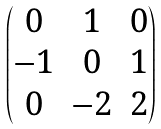<formula> <loc_0><loc_0><loc_500><loc_500>\begin{pmatrix} 0 & 1 & 0 \\ - 1 & 0 & 1 \\ 0 & - 2 & 2 \end{pmatrix}</formula> 